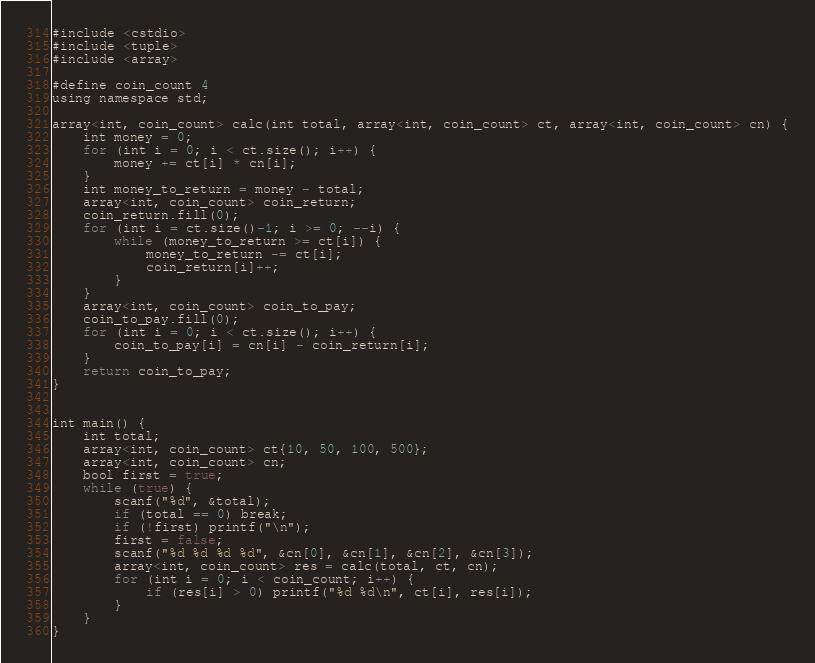Convert code to text. <code><loc_0><loc_0><loc_500><loc_500><_Scala_>#include <cstdio>
#include <tuple>
#include <array>

#define coin_count 4
using namespace std;

array<int, coin_count> calc(int total, array<int, coin_count> ct, array<int, coin_count> cn) {
	int money = 0;
	for (int i = 0; i < ct.size(); i++) {
		money += ct[i] * cn[i];
	}
	int money_to_return = money - total;
	array<int, coin_count> coin_return;
	coin_return.fill(0);
	for (int i = ct.size()-1; i >= 0; --i) {
		while (money_to_return >= ct[i]) {
			money_to_return -= ct[i];
			coin_return[i]++;
		}
	}
	array<int, coin_count> coin_to_pay;
	coin_to_pay.fill(0);
	for (int i = 0; i < ct.size(); i++) {
		coin_to_pay[i] = cn[i] - coin_return[i];
	}
	return coin_to_pay;
}


int main() {
	int total;
	array<int, coin_count> ct{10, 50, 100, 500};
	array<int, coin_count> cn;
	bool first = true;
	while (true) { 
		scanf("%d", &total);
		if (total == 0) break;
		if (!first) printf("\n");
		first = false;
		scanf("%d %d %d %d", &cn[0], &cn[1], &cn[2], &cn[3]);
		array<int, coin_count> res = calc(total, ct, cn);
		for (int i = 0; i < coin_count; i++) {
			if (res[i] > 0) printf("%d %d\n", ct[i], res[i]);
		}
	}
}

</code> 